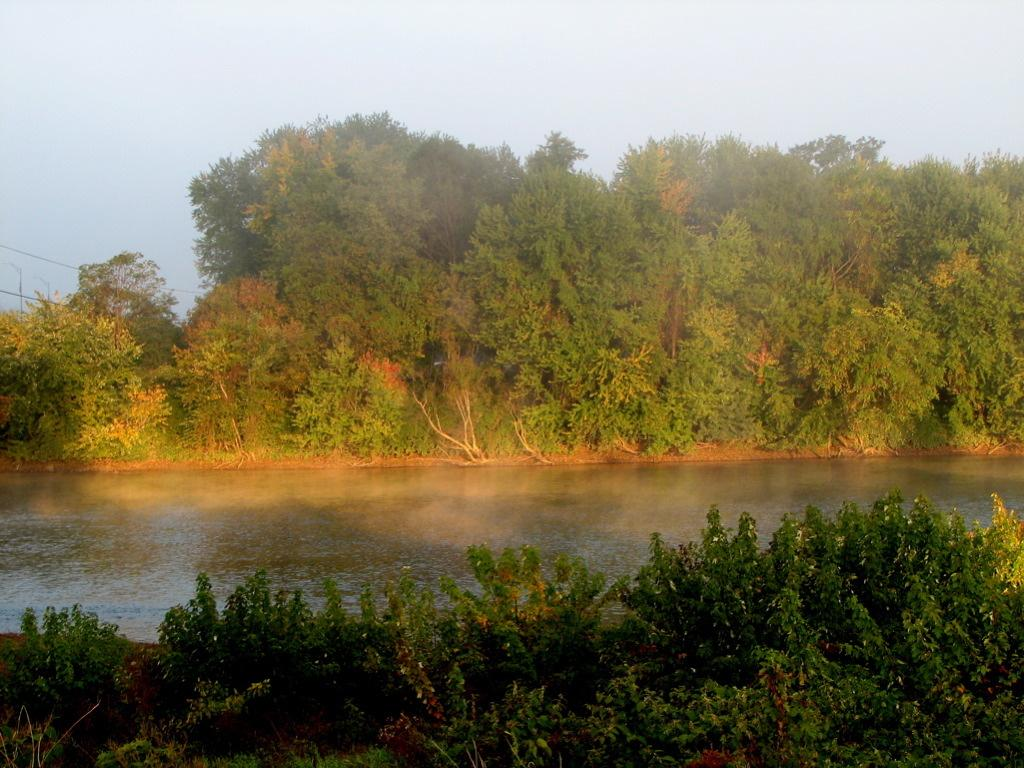What natural element can be seen in the image? Water is visible in the image. What type of vegetation is present in the image? There are trees and plants in the image. What part of the natural environment is visible in the image? The sky is visible in the image. What type of fire can be seen burning in the image? There is no fire present in the image. What type of wealth can be seen accumulated in the image? There is no wealth present in the image. 